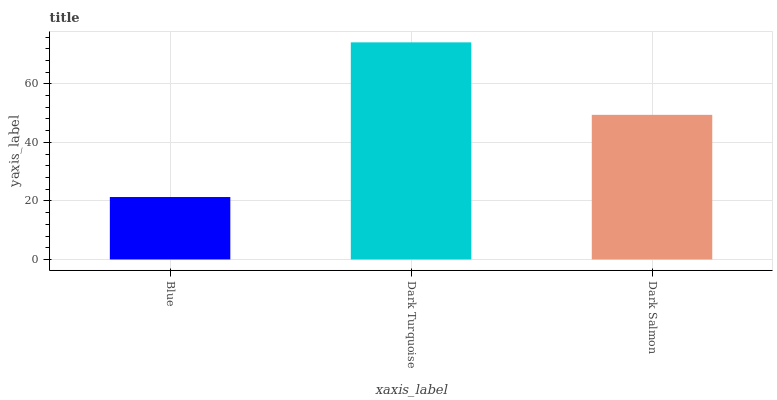Is Blue the minimum?
Answer yes or no. Yes. Is Dark Turquoise the maximum?
Answer yes or no. Yes. Is Dark Salmon the minimum?
Answer yes or no. No. Is Dark Salmon the maximum?
Answer yes or no. No. Is Dark Turquoise greater than Dark Salmon?
Answer yes or no. Yes. Is Dark Salmon less than Dark Turquoise?
Answer yes or no. Yes. Is Dark Salmon greater than Dark Turquoise?
Answer yes or no. No. Is Dark Turquoise less than Dark Salmon?
Answer yes or no. No. Is Dark Salmon the high median?
Answer yes or no. Yes. Is Dark Salmon the low median?
Answer yes or no. Yes. Is Blue the high median?
Answer yes or no. No. Is Blue the low median?
Answer yes or no. No. 